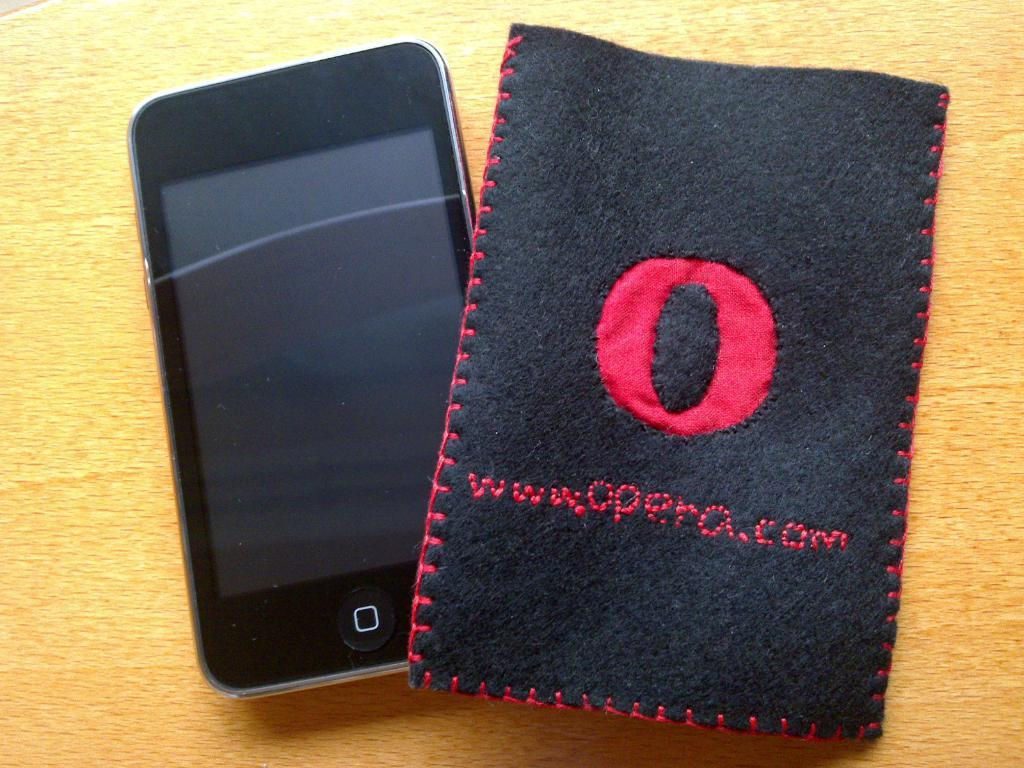<image>
Relay a brief, clear account of the picture shown. A cell phone is sitting next to a cloth stitched with www.opera.com 